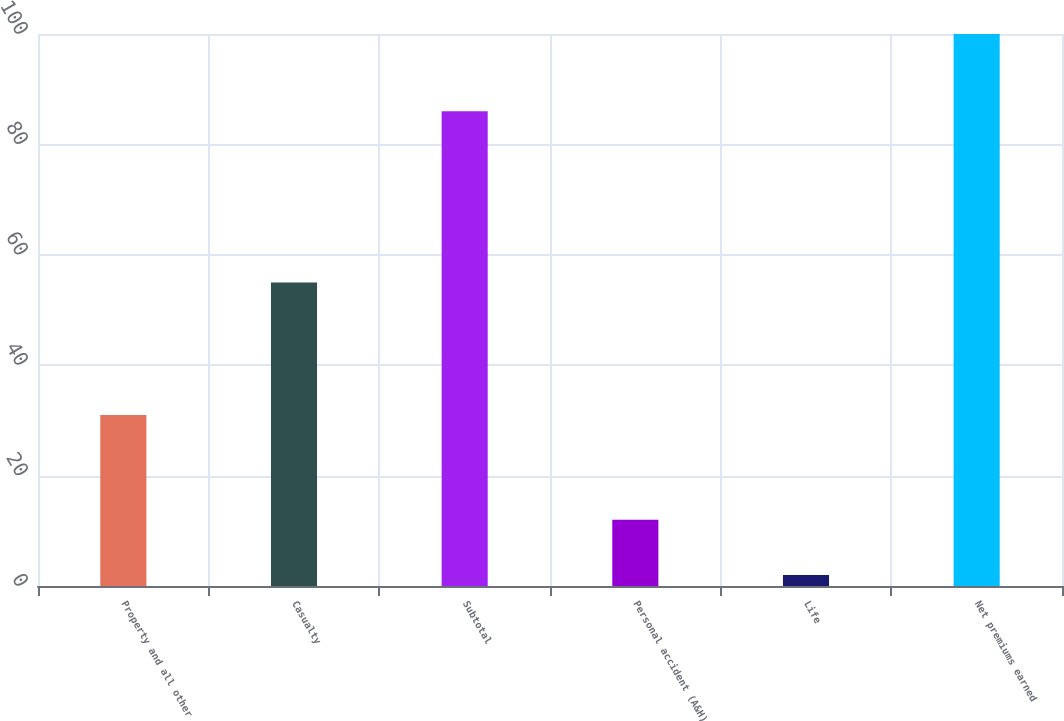<chart> <loc_0><loc_0><loc_500><loc_500><bar_chart><fcel>Property and all other<fcel>Casualty<fcel>Subtotal<fcel>Personal accident (A&H)<fcel>Life<fcel>Net premiums earned<nl><fcel>31<fcel>55<fcel>86<fcel>12<fcel>2<fcel>100<nl></chart> 